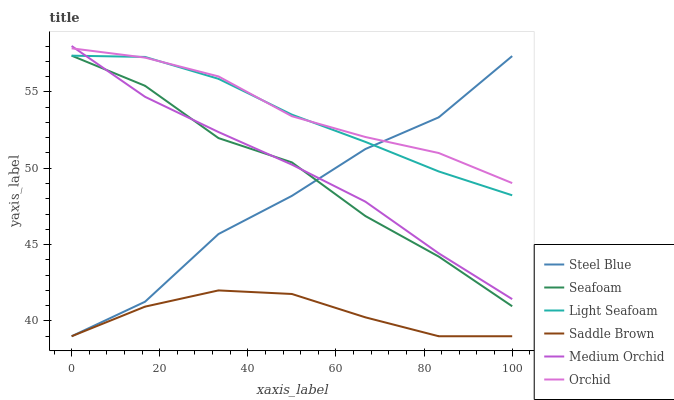Does Saddle Brown have the minimum area under the curve?
Answer yes or no. Yes. Does Orchid have the maximum area under the curve?
Answer yes or no. Yes. Does Steel Blue have the minimum area under the curve?
Answer yes or no. No. Does Steel Blue have the maximum area under the curve?
Answer yes or no. No. Is Medium Orchid the smoothest?
Answer yes or no. Yes. Is Steel Blue the roughest?
Answer yes or no. Yes. Is Seafoam the smoothest?
Answer yes or no. No. Is Seafoam the roughest?
Answer yes or no. No. Does Steel Blue have the lowest value?
Answer yes or no. Yes. Does Seafoam have the lowest value?
Answer yes or no. No. Does Medium Orchid have the highest value?
Answer yes or no. Yes. Does Steel Blue have the highest value?
Answer yes or no. No. Is Saddle Brown less than Medium Orchid?
Answer yes or no. Yes. Is Orchid greater than Saddle Brown?
Answer yes or no. Yes. Does Light Seafoam intersect Steel Blue?
Answer yes or no. Yes. Is Light Seafoam less than Steel Blue?
Answer yes or no. No. Is Light Seafoam greater than Steel Blue?
Answer yes or no. No. Does Saddle Brown intersect Medium Orchid?
Answer yes or no. No. 